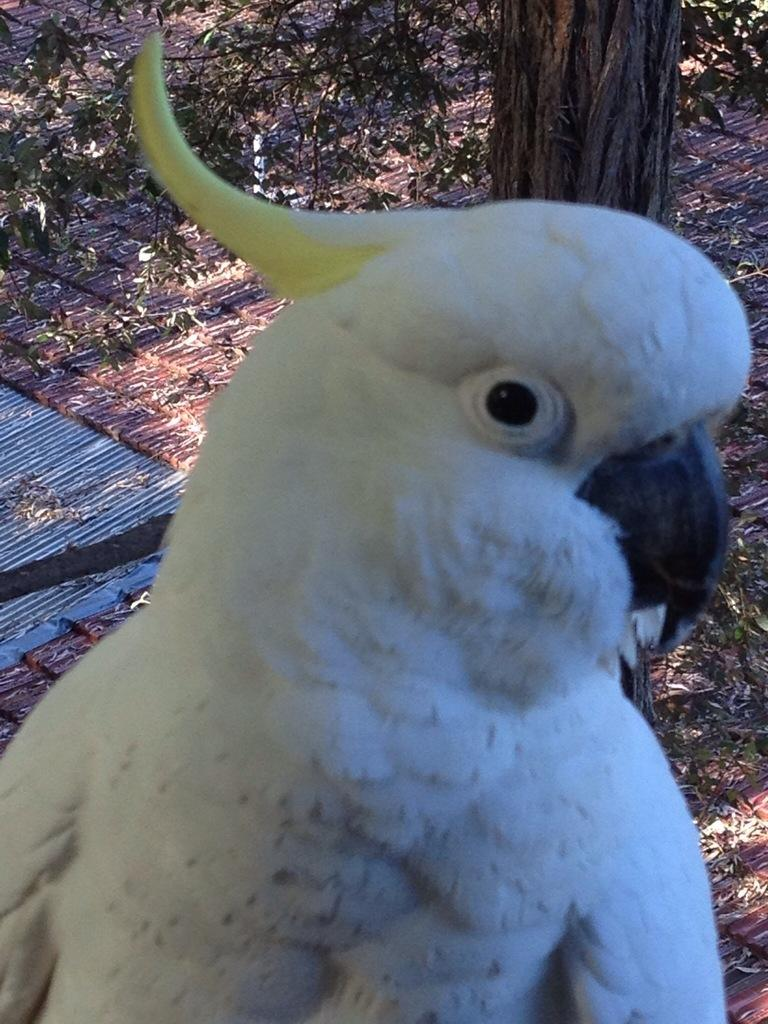What type of bird is in the image? There is a white parrot in the image. Where is the parrot located in relation to the image? The parrot is in the foreground. What can be seen in the background of the image? There are leaves and a tree trunk visible in the background of the image. What type of mine can be seen in the image? There is no mine present in the image; it features a white parrot in the foreground and leaves and a tree trunk in the background. 